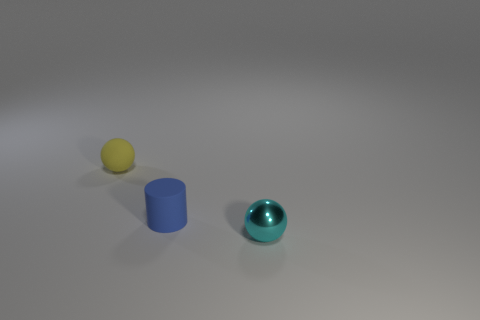Add 3 tiny matte things. How many objects exist? 6 Subtract all balls. How many objects are left? 1 Subtract all yellow objects. Subtract all tiny matte objects. How many objects are left? 0 Add 1 yellow matte spheres. How many yellow matte spheres are left? 2 Add 1 small metal cylinders. How many small metal cylinders exist? 1 Subtract 0 green cylinders. How many objects are left? 3 